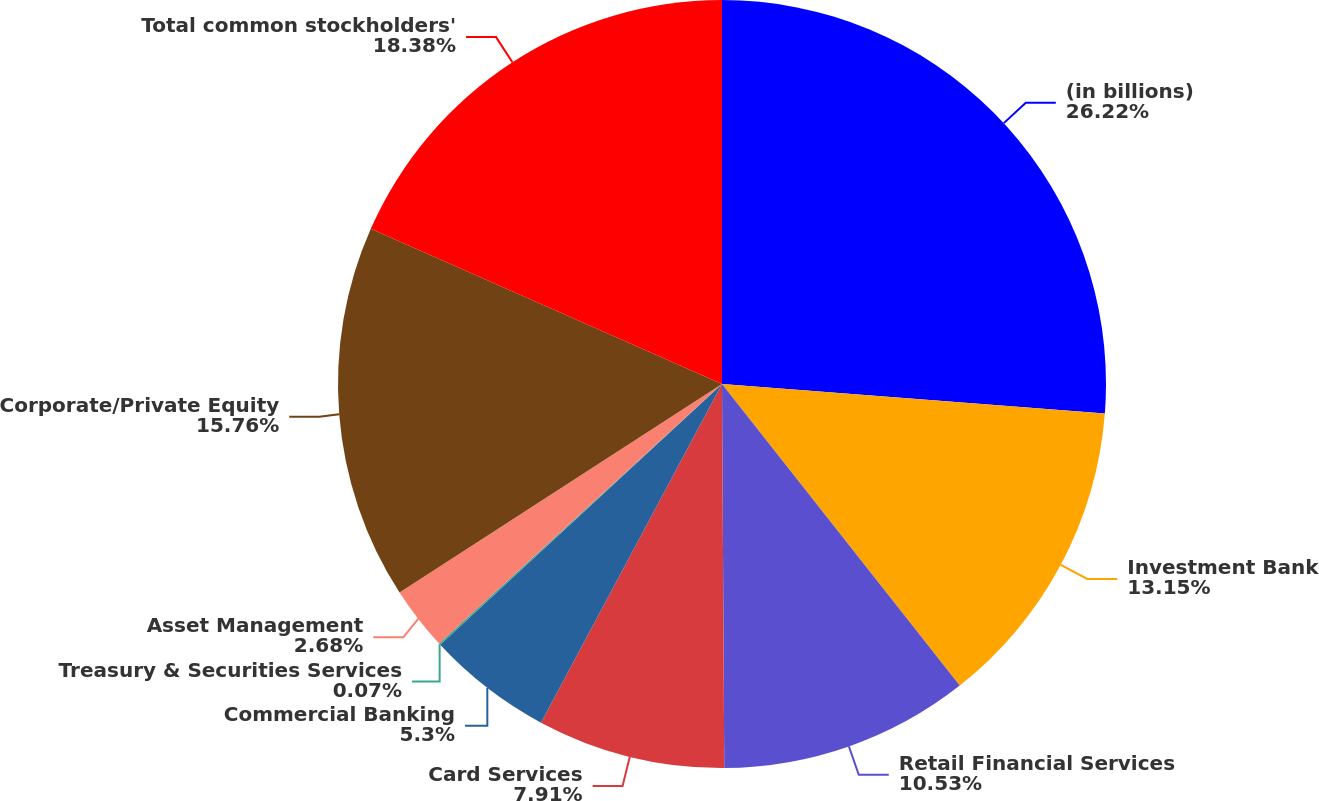Convert chart to OTSL. <chart><loc_0><loc_0><loc_500><loc_500><pie_chart><fcel>(in billions)<fcel>Investment Bank<fcel>Retail Financial Services<fcel>Card Services<fcel>Commercial Banking<fcel>Treasury & Securities Services<fcel>Asset Management<fcel>Corporate/Private Equity<fcel>Total common stockholders'<nl><fcel>26.23%<fcel>13.15%<fcel>10.53%<fcel>7.91%<fcel>5.3%<fcel>0.07%<fcel>2.68%<fcel>15.76%<fcel>18.38%<nl></chart> 